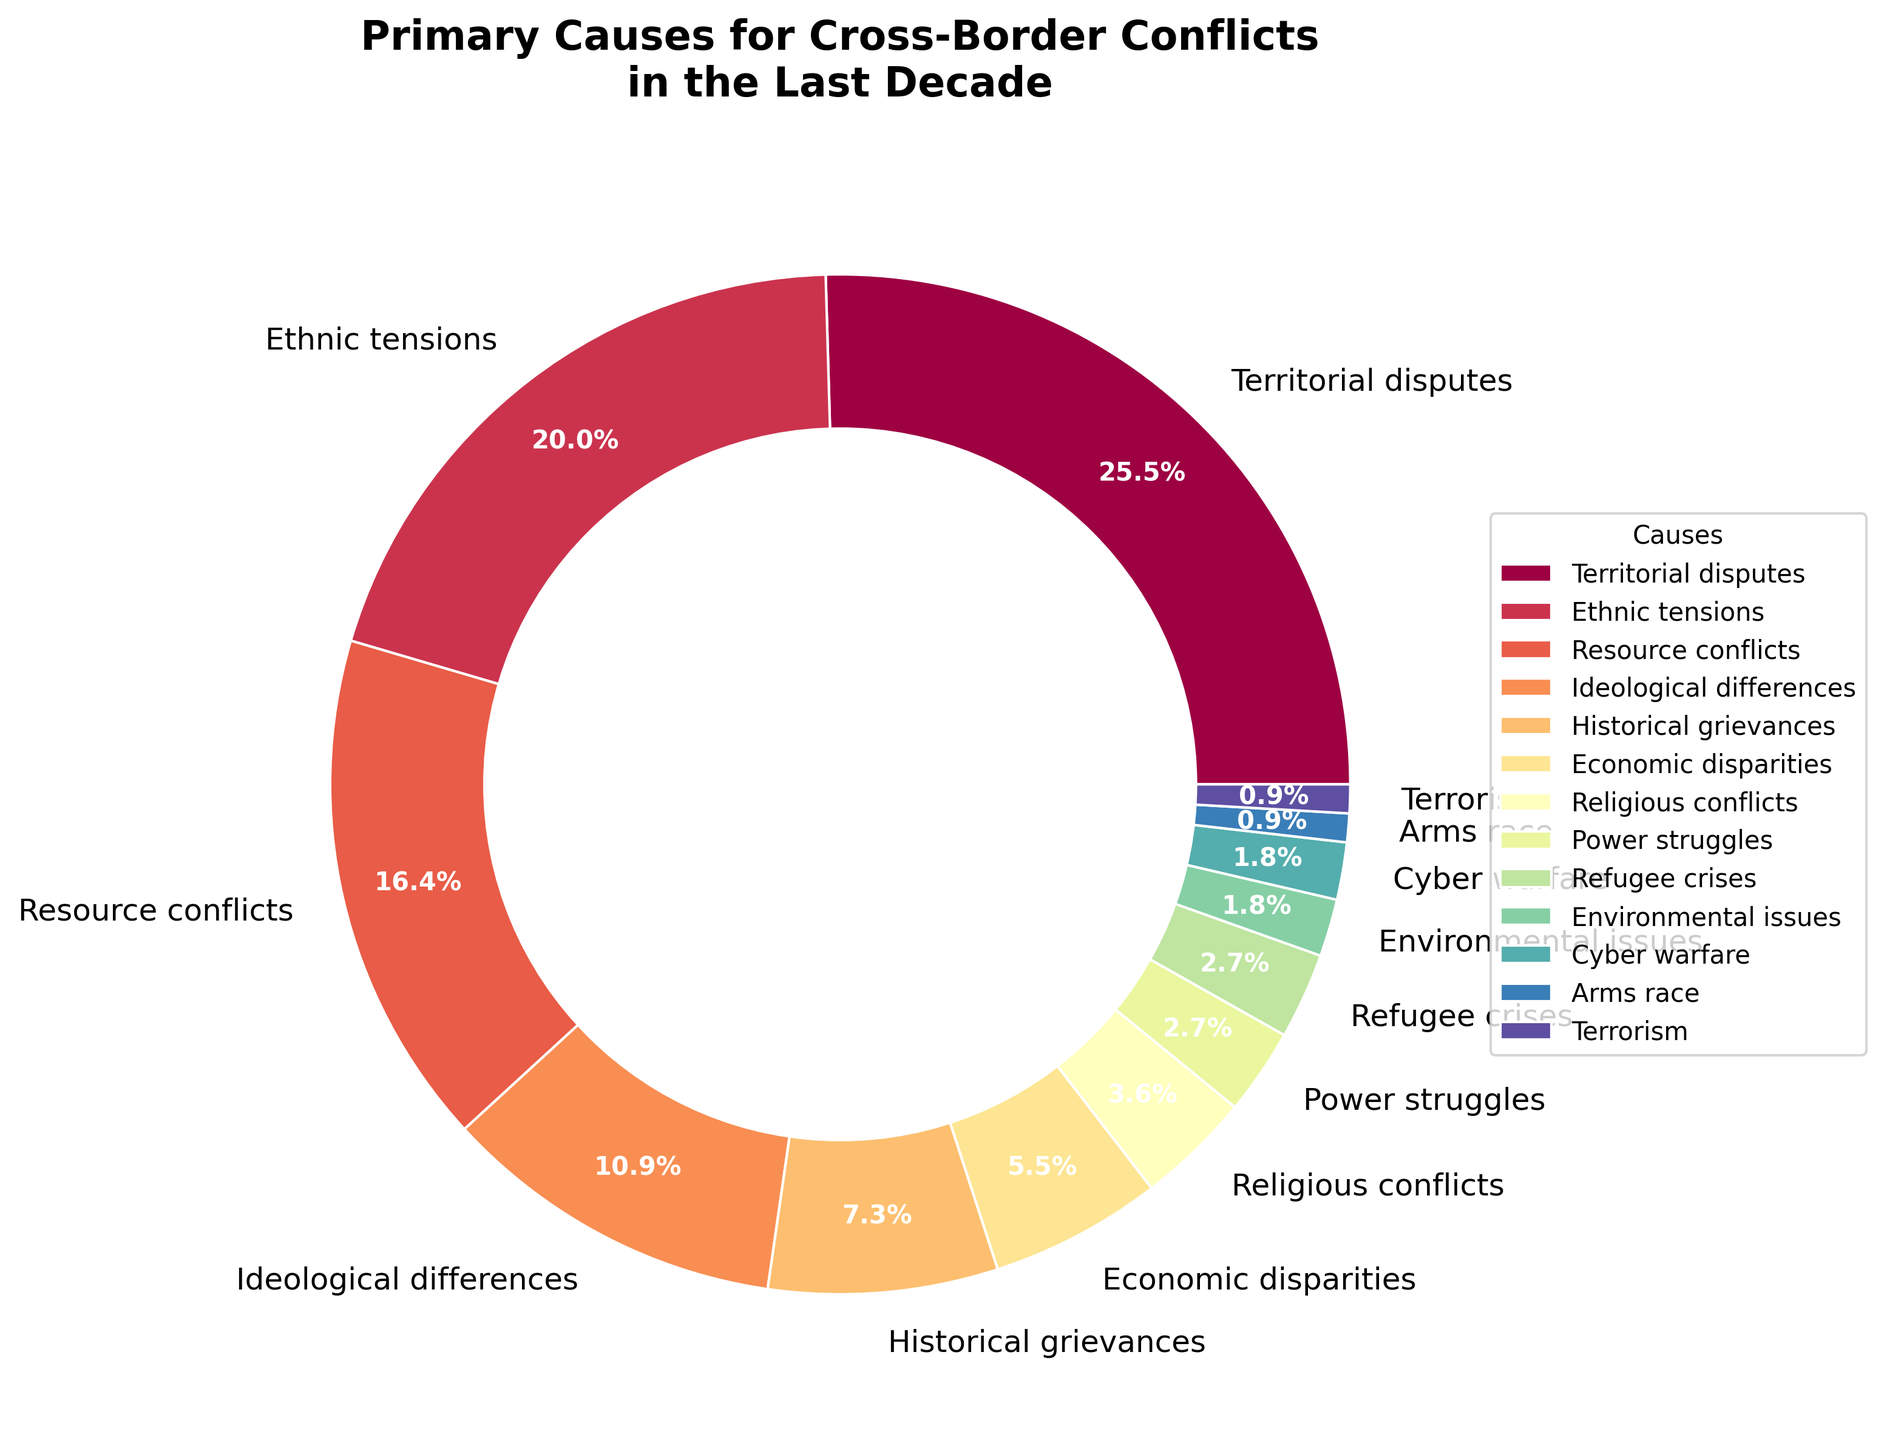Which cause has the highest percentage in the pie chart? The segment representing "Territorial disputes" has the largest size in the pie chart, indicating it has the highest percentage.
Answer: Territorial disputes Compare the percentages for "Ethnic tensions" and "Religious conflicts". Which one is higher and by how much? By observing the legend and the sizes of the pie chart segments, "Ethnic tensions" has a higher percentage at 22%, whereas "Religious conflicts" is at 4%. Thus, the difference is 22% - 4%.
Answer: Ethnic tensions by 18% What is the combined percentage of "Resource conflicts" and "Ideological differences"? To find the combined percentage, add the percentages for "Resource conflicts" (18%) and "Ideological differences" (12%).
Answer: 30% How does the percentage of "Historical grievances" compare to that of "Economic disparities"? "Historical grievances" account for 8% while "Economic disparities" account for 6%. Subtract the smaller percentage from the larger (8% - 6%).
Answer: Historical grievances is 2% higher What is the total percentage represented by causes less than or equal to 3%? Identify the causes with percentages of 3% or lower: "Power struggles" (3%), "Refugee crises" (3%), "Environmental issues" (2%), "Cyber warfare" (2%), "Arms race" (1%), and "Terrorism" (1%). Sum these percentages: 3% + 3% + 2% + 2% + 1% + 1%.
Answer: 12% Which cause is represented by the smallest segment, and what is its percentage? Examining the pie chart, the segment for "Arms race" and "Terrorism" are the smallest. Both represent 1%.
Answer: Arms race and Terrorism at 1% each Among all causes, which one is visually represented with the darkest color? In the pie chart, the segment for "Territorial disputes" appears to be represented with the darkest color, as it uses the starting color of the spectral colormap.
Answer: Territorial disputes What's the difference in percentage points between "Resource conflicts" and the total percentage of "Environmental issues" and "Cyber warfare"? "Resource conflicts" is 18%. "Environmental issues" and "Cyber warfare" are both 2%, summing to 4%. The difference is 18% - 4%.
Answer: 14 percentage points How many causes are represented with a percentage higher than 10%? By analyzing the pie chart, "Territorial disputes" (28%), "Ethnic tensions" (22%), and "Resource conflicts" (18%), "Ideological differences" (12%) are higher than 10%. Count these categories.
Answer: 4 causes 